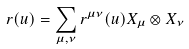<formula> <loc_0><loc_0><loc_500><loc_500>r ( u ) = \sum _ { \mu , \nu } r ^ { \mu \nu } ( u ) X _ { \mu } \otimes X _ { \nu }</formula> 